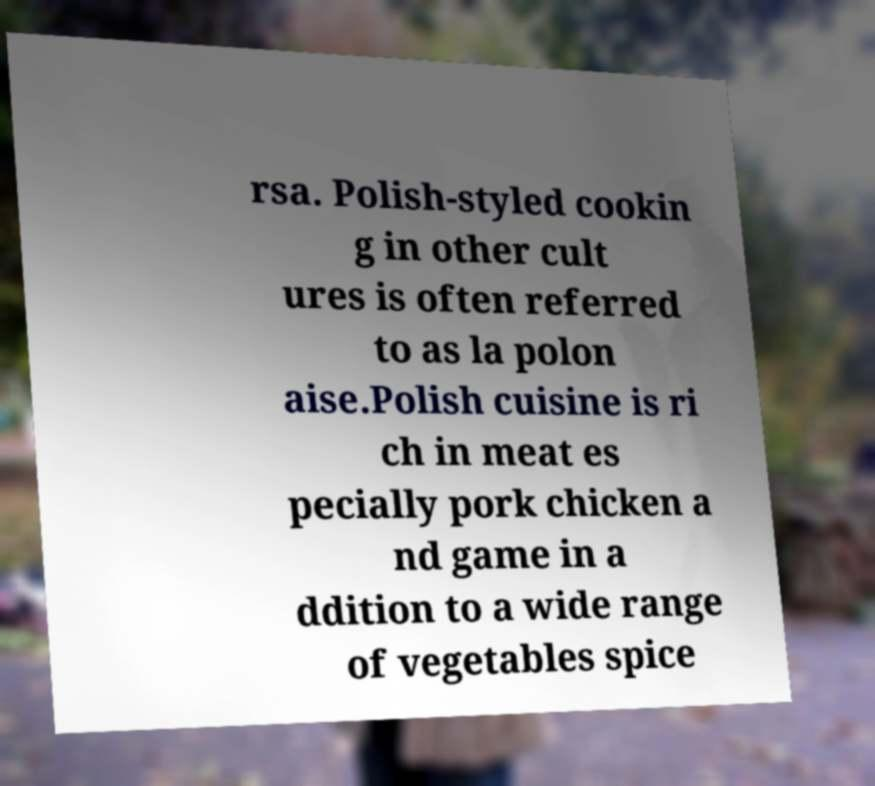There's text embedded in this image that I need extracted. Can you transcribe it verbatim? rsa. Polish-styled cookin g in other cult ures is often referred to as la polon aise.Polish cuisine is ri ch in meat es pecially pork chicken a nd game in a ddition to a wide range of vegetables spice 